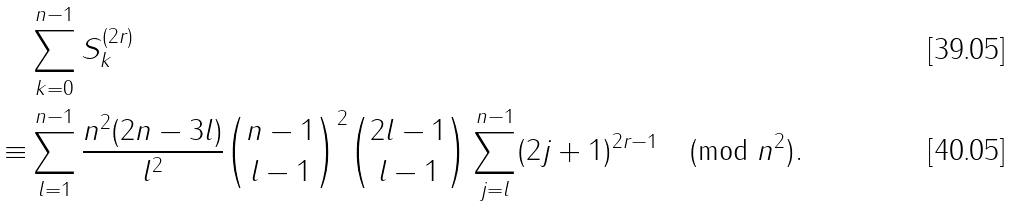<formula> <loc_0><loc_0><loc_500><loc_500>& \sum _ { k = 0 } ^ { n - 1 } S _ { k } ^ { ( 2 r ) } \\ \equiv & \sum _ { l = 1 } ^ { n - 1 } \frac { n ^ { 2 } ( 2 n - 3 l ) } { l ^ { 2 } } \binom { n - 1 } { l - 1 } ^ { 2 } \binom { 2 l - 1 } { l - 1 } \sum _ { j = l } ^ { n - 1 } ( 2 j + 1 ) ^ { 2 r - 1 } \pmod { n ^ { 2 } } .</formula> 